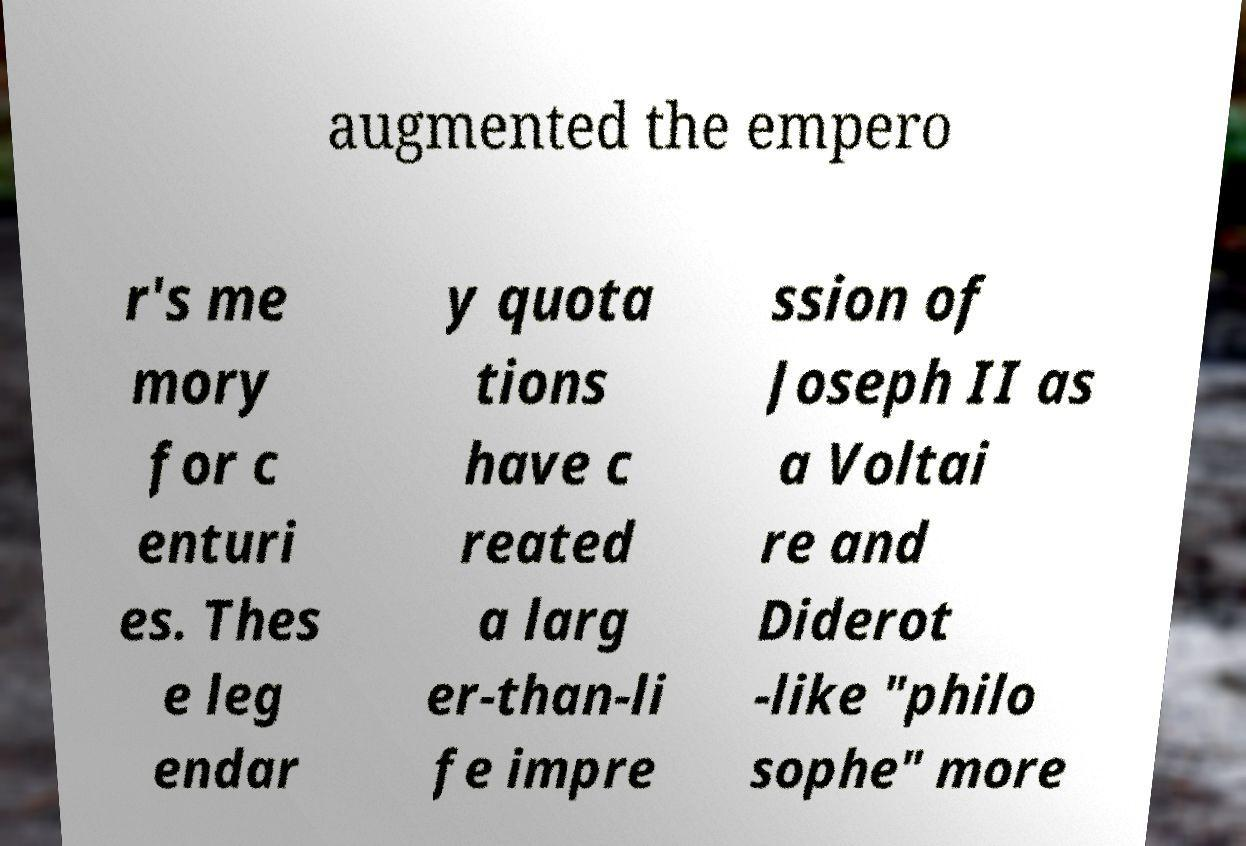What messages or text are displayed in this image? I need them in a readable, typed format. augmented the empero r's me mory for c enturi es. Thes e leg endar y quota tions have c reated a larg er-than-li fe impre ssion of Joseph II as a Voltai re and Diderot -like "philo sophe" more 